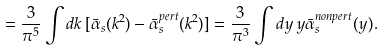<formula> <loc_0><loc_0><loc_500><loc_500>= \frac { 3 } { \pi ^ { 5 } } \int d k \, [ \bar { \alpha } _ { s } ( k ^ { 2 } ) - \bar { \alpha } ^ { p e r t } _ { s } ( k ^ { 2 } ) ] = \frac { 3 } { \pi ^ { 3 } } \int d y \, y \bar { \alpha } ^ { n o n p e r t } _ { s } ( y ) .</formula> 